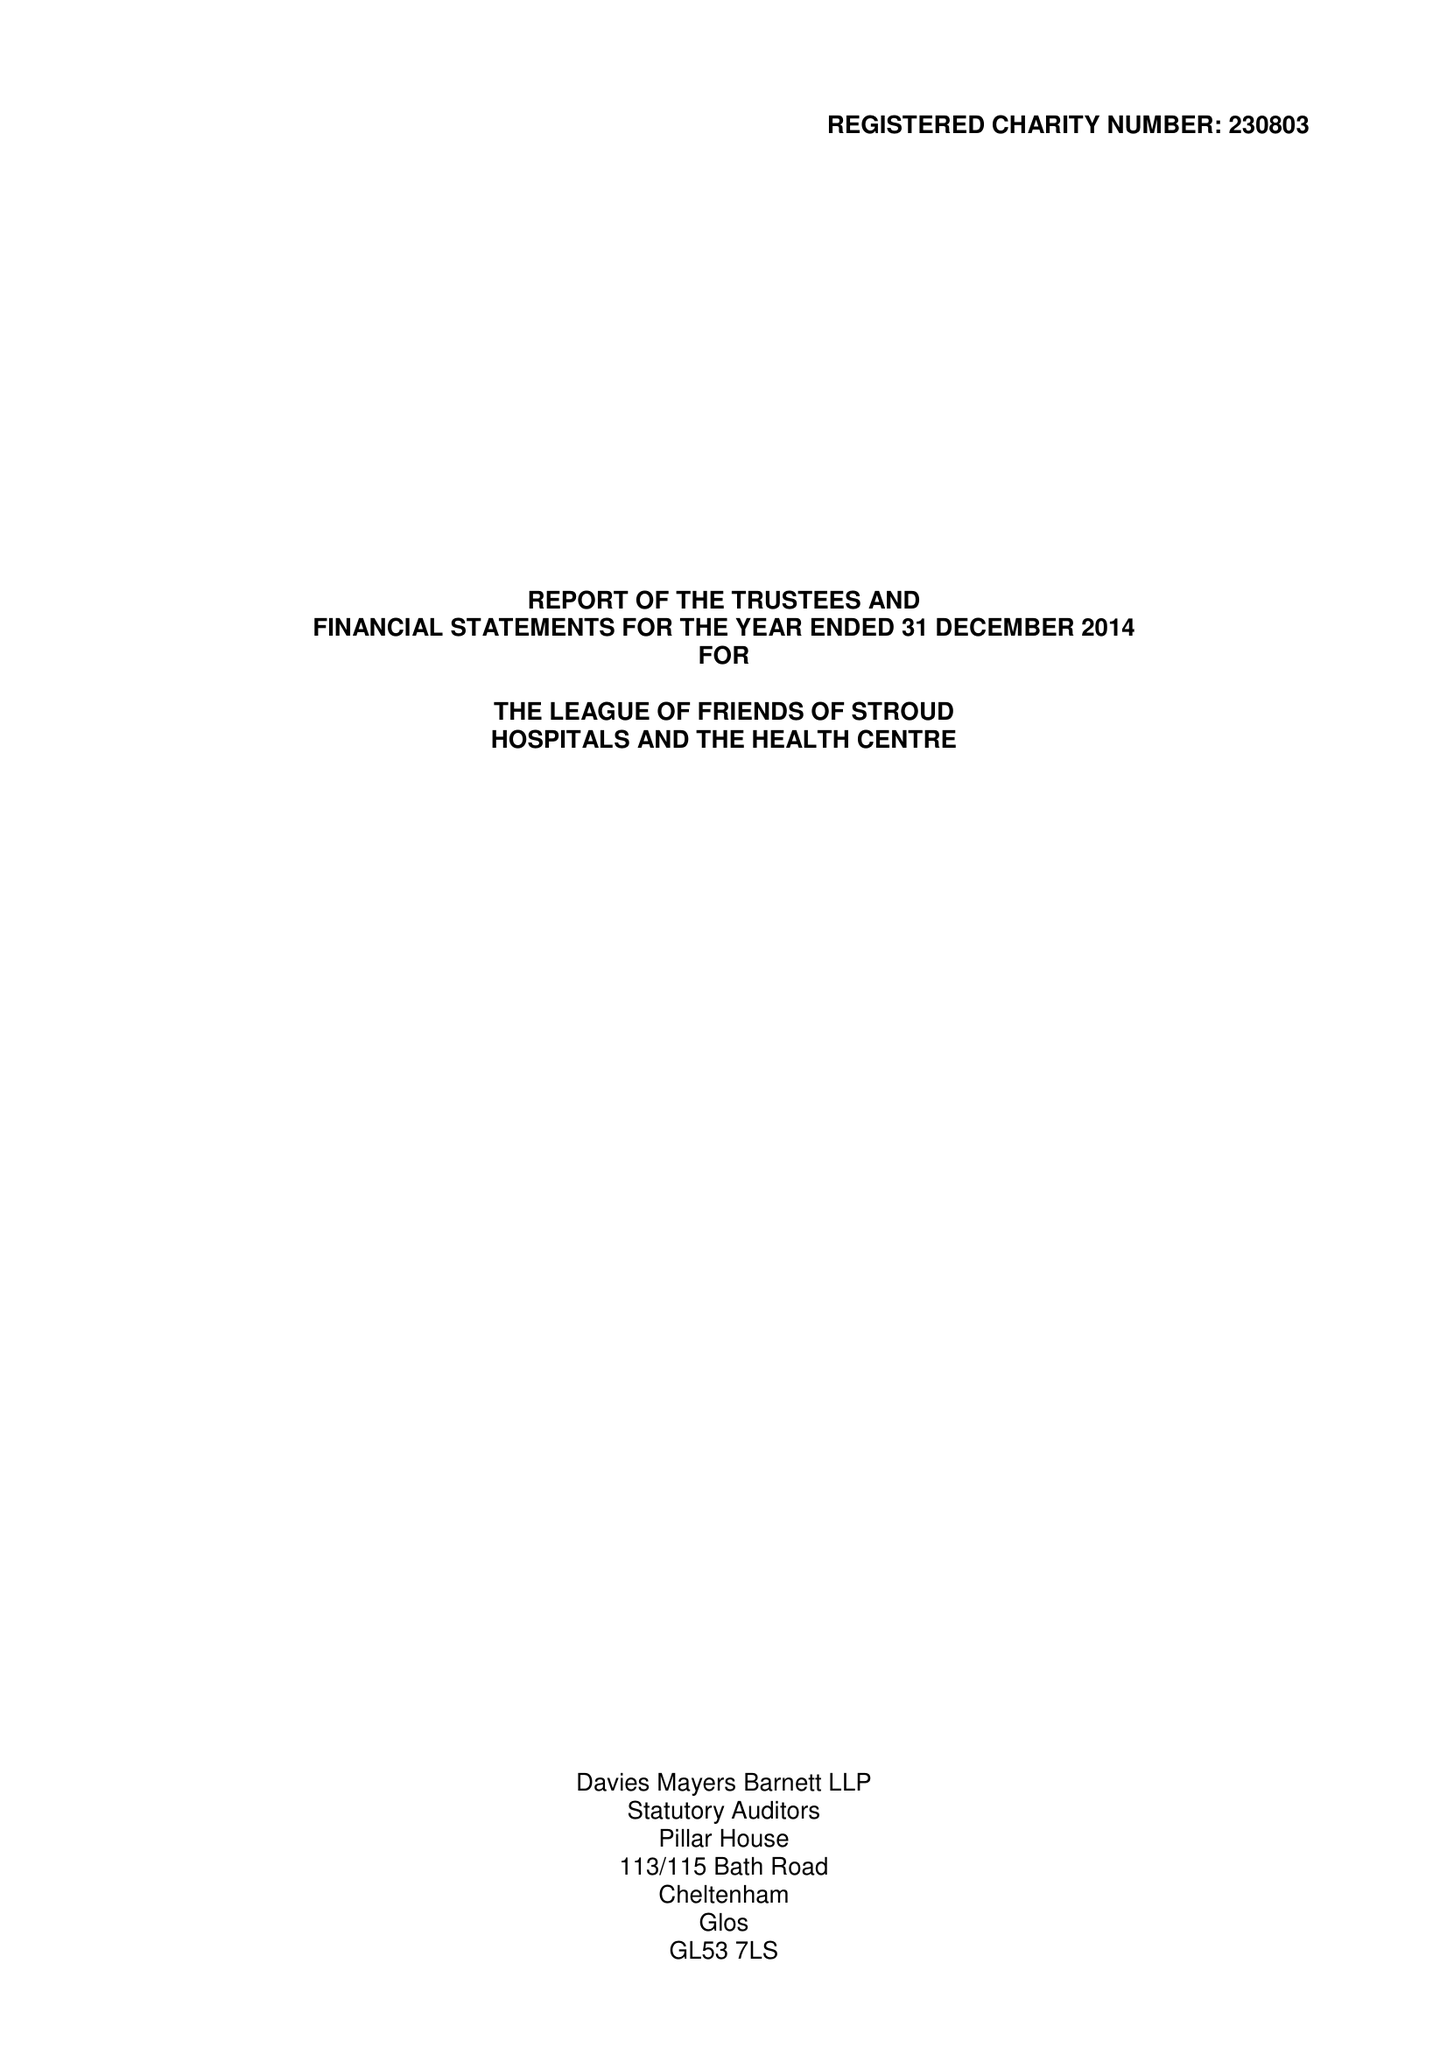What is the value for the charity_name?
Answer the question using a single word or phrase. The League Of Friends Of Stroud Hospitals and The Health Centre 